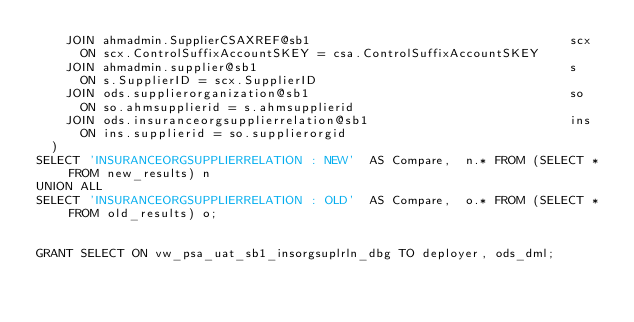Convert code to text. <code><loc_0><loc_0><loc_500><loc_500><_SQL_>    JOIN ahmadmin.SupplierCSAXREF@sb1                                   scx
      ON scx.ControlSuffixAccountSKEY = csa.ControlSuffixAccountSKEY
    JOIN ahmadmin.supplier@sb1                                          s
      ON s.SupplierID = scx.SupplierID 
    JOIN ods.supplierorganization@sb1                                   so
      ON so.ahmsupplierid = s.ahmsupplierid                             
    JOIN ods.insuranceorgsupplierrelation@sb1                           ins
      ON ins.supplierid = so.supplierorgid
  )
SELECT 'INSURANCEORGSUPPLIERRELATION : NEW'  AS Compare,  n.* FROM (SELECT * FROM new_results) n
UNION ALL
SELECT 'INSURANCEORGSUPPLIERRELATION : OLD'  AS Compare,  o.* FROM (SELECT * FROM old_results) o;


GRANT SELECT ON vw_psa_uat_sb1_insorgsuplrln_dbg TO deployer, ods_dml;</code> 